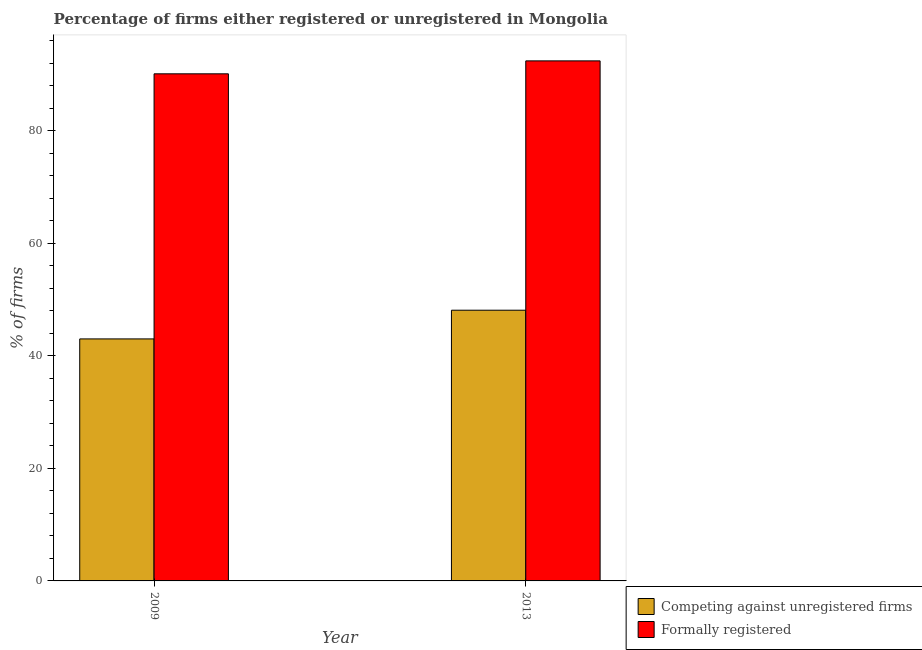How many different coloured bars are there?
Keep it short and to the point. 2. How many bars are there on the 1st tick from the left?
Provide a short and direct response. 2. How many bars are there on the 1st tick from the right?
Offer a terse response. 2. What is the label of the 2nd group of bars from the left?
Make the answer very short. 2013. In how many cases, is the number of bars for a given year not equal to the number of legend labels?
Provide a succinct answer. 0. What is the percentage of registered firms in 2013?
Give a very brief answer. 48.1. Across all years, what is the maximum percentage of registered firms?
Provide a succinct answer. 48.1. In which year was the percentage of registered firms maximum?
Ensure brevity in your answer.  2013. In which year was the percentage of formally registered firms minimum?
Keep it short and to the point. 2009. What is the total percentage of formally registered firms in the graph?
Ensure brevity in your answer.  182.5. What is the difference between the percentage of registered firms in 2009 and that in 2013?
Your answer should be very brief. -5.1. What is the difference between the percentage of registered firms in 2009 and the percentage of formally registered firms in 2013?
Your response must be concise. -5.1. What is the average percentage of formally registered firms per year?
Ensure brevity in your answer.  91.25. What is the ratio of the percentage of formally registered firms in 2009 to that in 2013?
Your response must be concise. 0.98. In how many years, is the percentage of registered firms greater than the average percentage of registered firms taken over all years?
Your answer should be very brief. 1. What does the 2nd bar from the left in 2009 represents?
Offer a terse response. Formally registered. What does the 1st bar from the right in 2013 represents?
Make the answer very short. Formally registered. Are all the bars in the graph horizontal?
Your answer should be very brief. No. Does the graph contain any zero values?
Your answer should be compact. No. Does the graph contain grids?
Keep it short and to the point. No. Where does the legend appear in the graph?
Offer a very short reply. Bottom right. How many legend labels are there?
Offer a very short reply. 2. What is the title of the graph?
Ensure brevity in your answer.  Percentage of firms either registered or unregistered in Mongolia. What is the label or title of the X-axis?
Offer a very short reply. Year. What is the label or title of the Y-axis?
Provide a short and direct response. % of firms. What is the % of firms of Competing against unregistered firms in 2009?
Give a very brief answer. 43. What is the % of firms in Formally registered in 2009?
Ensure brevity in your answer.  90.1. What is the % of firms in Competing against unregistered firms in 2013?
Provide a succinct answer. 48.1. What is the % of firms in Formally registered in 2013?
Provide a succinct answer. 92.4. Across all years, what is the maximum % of firms of Competing against unregistered firms?
Offer a very short reply. 48.1. Across all years, what is the maximum % of firms in Formally registered?
Offer a terse response. 92.4. Across all years, what is the minimum % of firms in Competing against unregistered firms?
Offer a very short reply. 43. Across all years, what is the minimum % of firms of Formally registered?
Offer a terse response. 90.1. What is the total % of firms in Competing against unregistered firms in the graph?
Your answer should be compact. 91.1. What is the total % of firms in Formally registered in the graph?
Keep it short and to the point. 182.5. What is the difference between the % of firms in Formally registered in 2009 and that in 2013?
Give a very brief answer. -2.3. What is the difference between the % of firms of Competing against unregistered firms in 2009 and the % of firms of Formally registered in 2013?
Keep it short and to the point. -49.4. What is the average % of firms in Competing against unregistered firms per year?
Make the answer very short. 45.55. What is the average % of firms of Formally registered per year?
Keep it short and to the point. 91.25. In the year 2009, what is the difference between the % of firms of Competing against unregistered firms and % of firms of Formally registered?
Your response must be concise. -47.1. In the year 2013, what is the difference between the % of firms in Competing against unregistered firms and % of firms in Formally registered?
Make the answer very short. -44.3. What is the ratio of the % of firms of Competing against unregistered firms in 2009 to that in 2013?
Ensure brevity in your answer.  0.89. What is the ratio of the % of firms of Formally registered in 2009 to that in 2013?
Make the answer very short. 0.98. What is the difference between the highest and the second highest % of firms in Competing against unregistered firms?
Provide a short and direct response. 5.1. What is the difference between the highest and the second highest % of firms of Formally registered?
Your response must be concise. 2.3. What is the difference between the highest and the lowest % of firms in Competing against unregistered firms?
Provide a short and direct response. 5.1. 